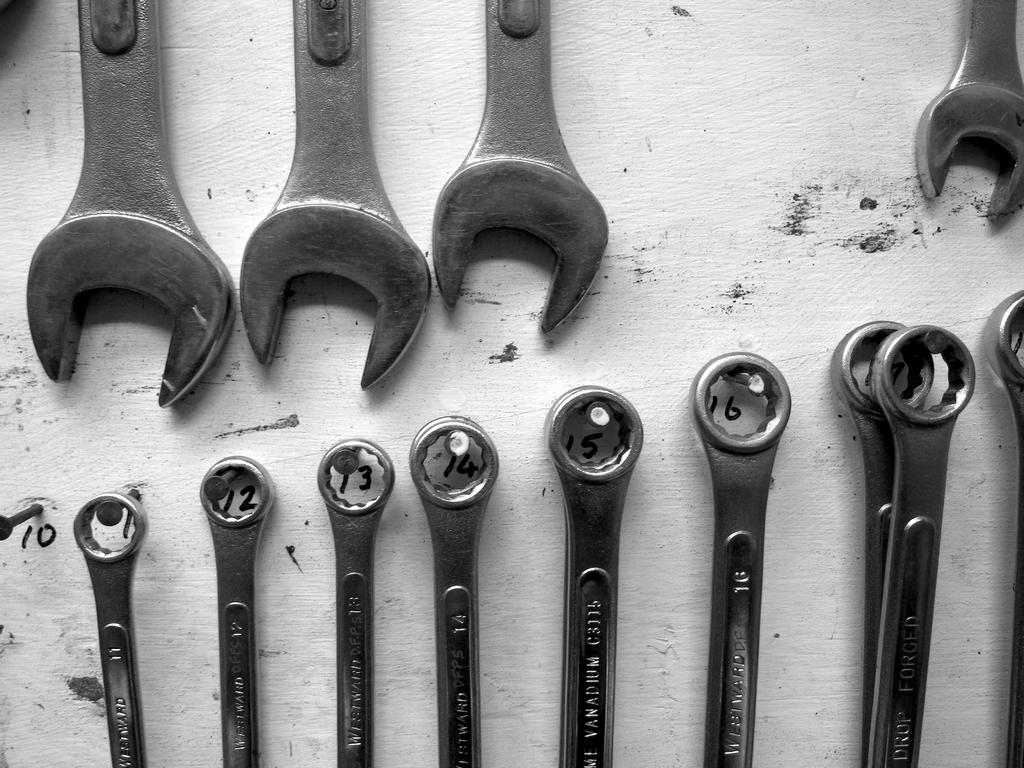What type of tools are in the image? There are wrenches in the image. How are some of the wrenches positioned? Some wrenches are hanging in the image. What can be seen in the background of the image? There is a white wall and numbers visible in the background of the image. How many pins are on the son's shirt in the image? There is no son or shirt with pins present in the image; it only features wrenches and a white wall with numbers in the background. 